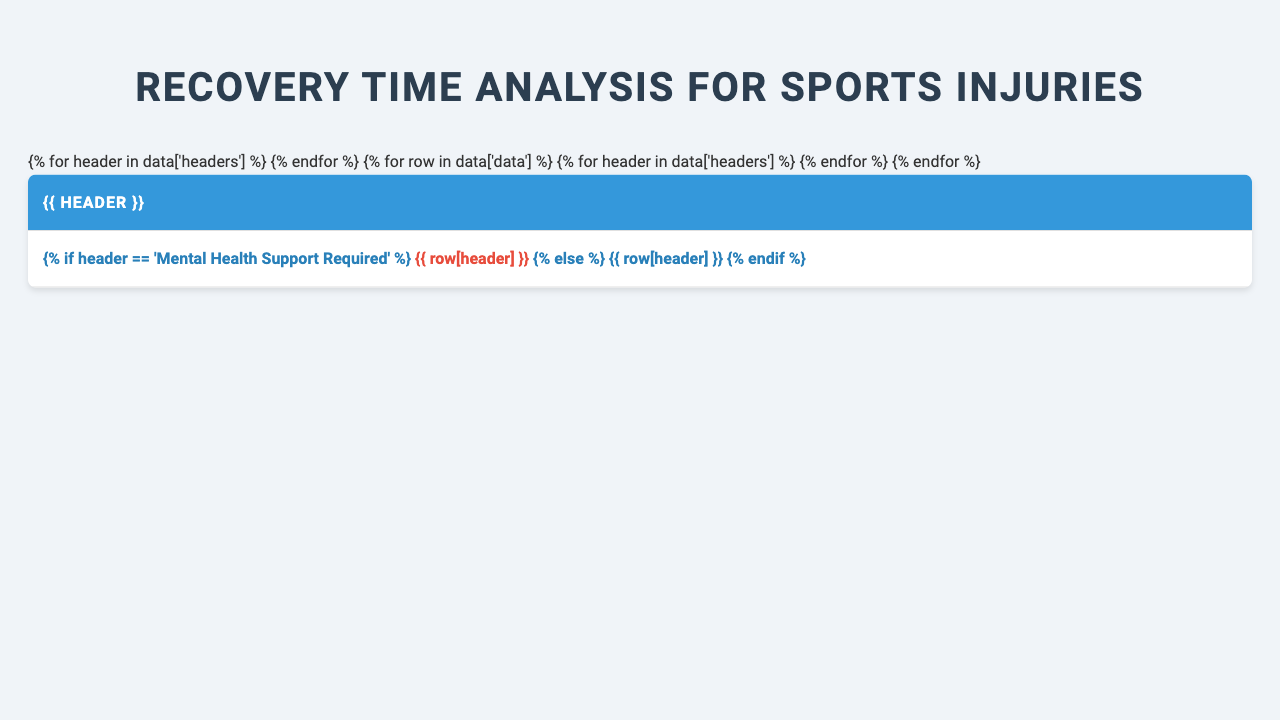What is the average recovery time for an ACL tear in soccer? The table indicates that the average recovery time for an ACL tear in soccer is listed directly under the "Average Recovery Time (weeks)" column for that injury type. The entry shows 36 weeks.
Answer: 36 weeks Which sport has the longest average recovery time? By scanning the "Average Recovery Time (weeks)" column, we see that the longest recovery time listed is 36 weeks, associated with the ACL tear in soccer.
Answer: Soccer What is the probability of full recovery for a tennis elbow injury? Looking under the "Probability of Full Recovery (%)" column, the entry for tennis elbow shows a probability of 90%.
Answer: 90% How many hours of recommended physical therapy per week are advised for a rotator cuff tear? The table specifies that the recommended physical therapy for a rotator cuff tear is 12 hours per week, as seen in the respective row of the table.
Answer: 12 hours What is the average recovery time for hamstring strains and stress fractures combined? The average recovery time for hamstring strain is 6 weeks and for stress fracture is 8 weeks. Adding them gives 6 + 8 = 14 weeks. To find the average, we divide by 2 (14/2) equals 7 weeks.
Answer: 7 weeks Is mental health support required for athletes with hamstring strains? In the column for "Mental Health Support Required," the entry for hamstring strains states "No," indicating that it is not required for this injury.
Answer: No What percentage of athletes fully recover from ankle sprains? From the "Probability of Full Recovery (%)" column, ankle sprains have a full recovery probability of 98%, as found directly in the corresponding row.
Answer: 98% What is the average impact on performance post-recovery for concussions and tennis elbows? The impact on performance post-recovery for concussions is -3% and for tennis elbows is -4%. Adding them gives -3 + (-4) = -7%. To average it, divide by 2 (-7/2 = -3.5%).
Answer: -3.5% Which injury type has the highest risk of re-injury? The maximum risk of re-injury percentage can be found by comparing the "Risk of Re-injury (%)" values across all rows. A hamstring strain has a risk of 25%, which is the highest listed.
Answer: Hamstring Strain What is the recommended pain management for an ACL tear? The table details the "Approved Pain Management" for an ACL tear as "NSAIDs, Ice therapy," found in the respective column and row.
Answer: NSAIDs, Ice therapy 